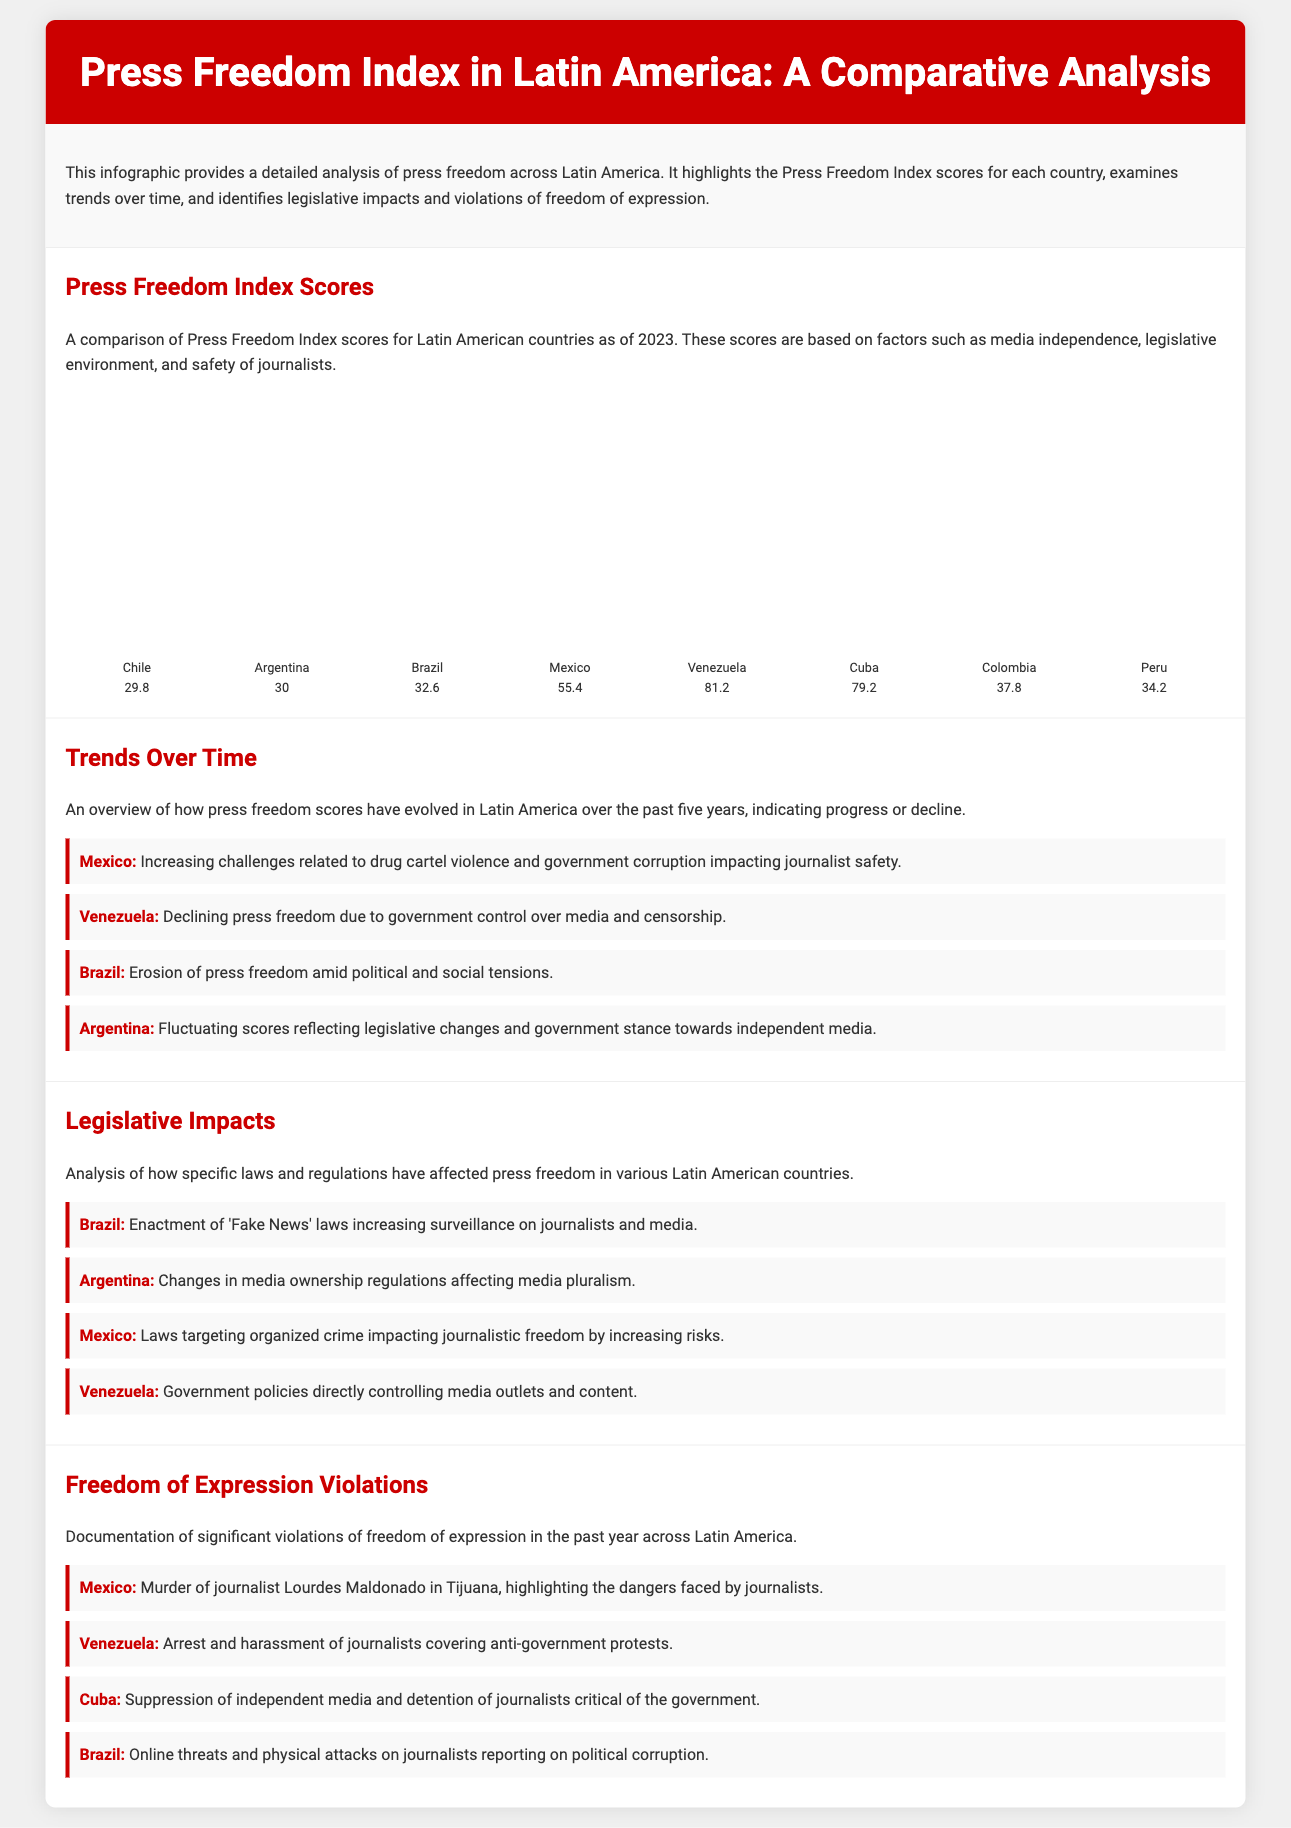What is the Press Freedom Index score for Chile? The document lists Chile's Press Freedom Index score as 29.8.
Answer: 29.8 Which country has the lowest Press Freedom Index score? According to the infographic, Venezuela has the lowest score of 81.2.
Answer: Venezuela What trend is observed for the press freedom score in Mexico? The document notes that Mexico faces increasing challenges impacting journalist safety.
Answer: Increasing challenges What legislative change affected Argentina's media? The infographic mentions changes in media ownership regulations affecting media pluralism.
Answer: Media ownership regulations What significant violation occurred in Cuba? The document states that there is suppression of independent media and detention of journalists.
Answer: Suppression of independent media Which country has an "Erosion of press freedom" amid tensions? The document identifies Brazil as experiencing erosion of press freedom amid political and social tensions.
Answer: Brazil What was a documented violation involving a journalist in Mexico? The document reports the murder of journalist Lourdes Maldonado in Tijuana.
Answer: Murder of Lourdes Maldonado What is the height of the bar representing Colombia's Press Freedom Index? The infographic shows Colombia's bar height at 62.2%.
Answer: 62.2% 